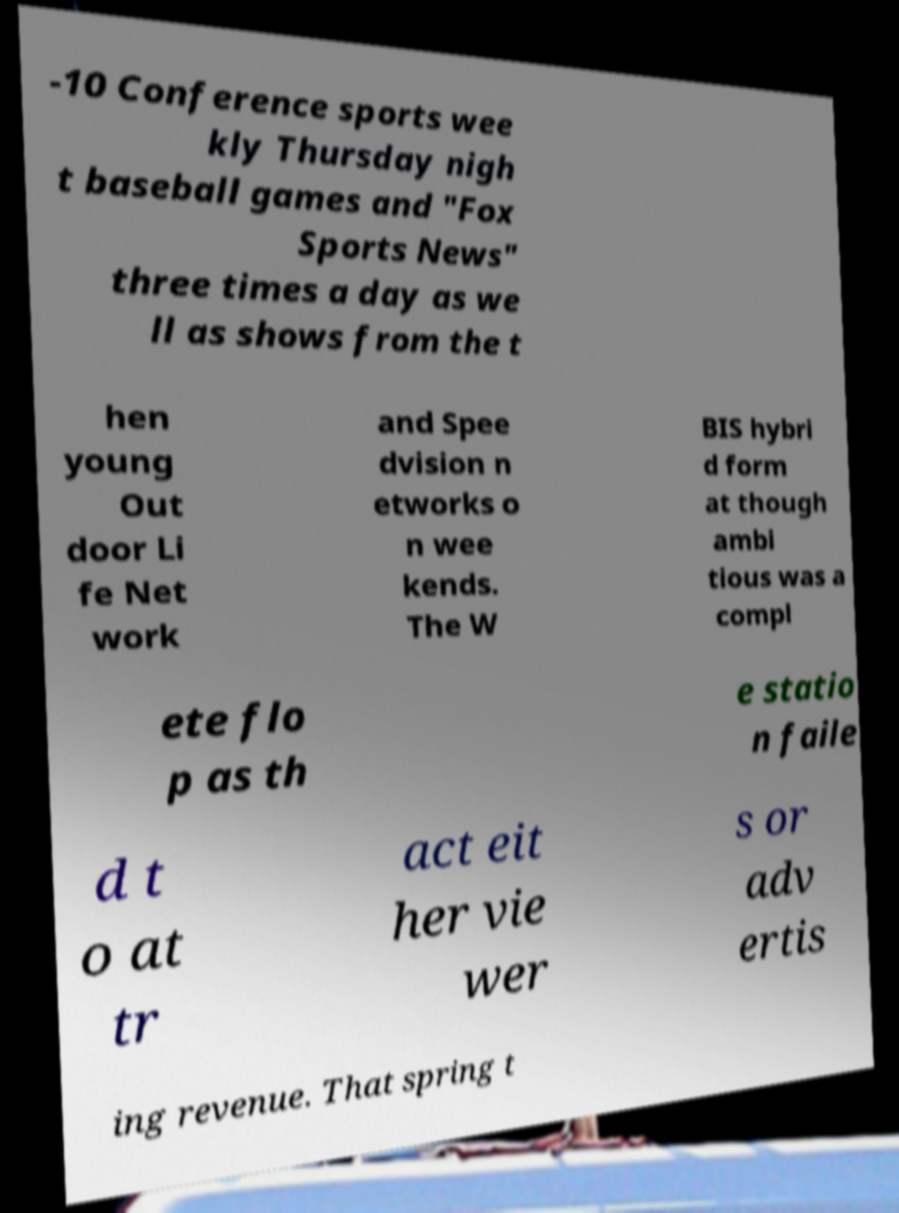For documentation purposes, I need the text within this image transcribed. Could you provide that? -10 Conference sports wee kly Thursday nigh t baseball games and "Fox Sports News" three times a day as we ll as shows from the t hen young Out door Li fe Net work and Spee dvision n etworks o n wee kends. The W BIS hybri d form at though ambi tious was a compl ete flo p as th e statio n faile d t o at tr act eit her vie wer s or adv ertis ing revenue. That spring t 